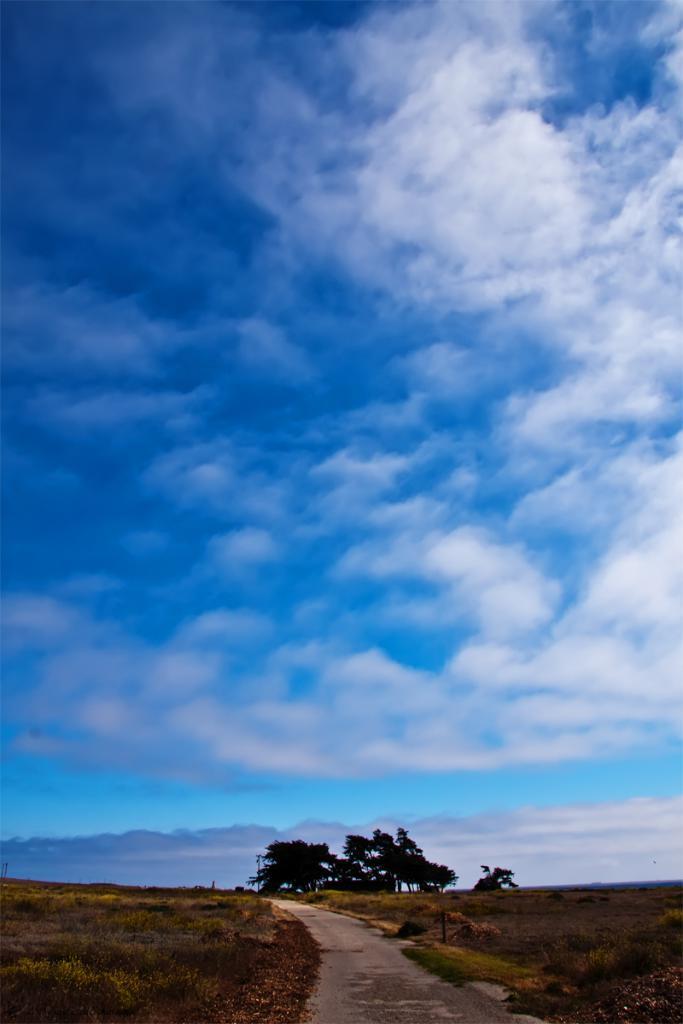Can you describe this image briefly? In this image, we can see trees and some plants. At the bottom, there is ground covered with grass and at the top, there are clouds in the sky. 